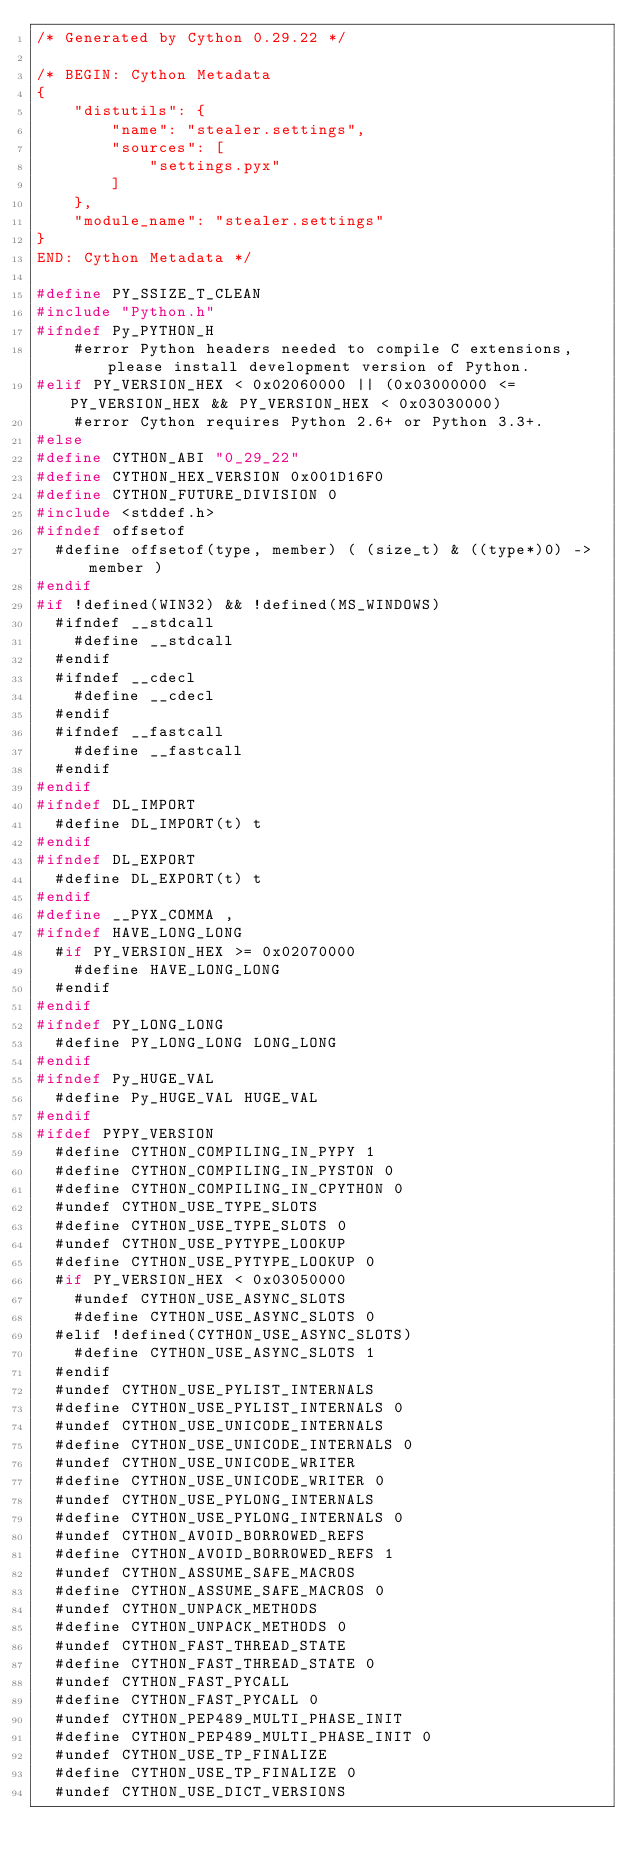<code> <loc_0><loc_0><loc_500><loc_500><_C_>/* Generated by Cython 0.29.22 */

/* BEGIN: Cython Metadata
{
    "distutils": {
        "name": "stealer.settings",
        "sources": [
            "settings.pyx"
        ]
    },
    "module_name": "stealer.settings"
}
END: Cython Metadata */

#define PY_SSIZE_T_CLEAN
#include "Python.h"
#ifndef Py_PYTHON_H
    #error Python headers needed to compile C extensions, please install development version of Python.
#elif PY_VERSION_HEX < 0x02060000 || (0x03000000 <= PY_VERSION_HEX && PY_VERSION_HEX < 0x03030000)
    #error Cython requires Python 2.6+ or Python 3.3+.
#else
#define CYTHON_ABI "0_29_22"
#define CYTHON_HEX_VERSION 0x001D16F0
#define CYTHON_FUTURE_DIVISION 0
#include <stddef.h>
#ifndef offsetof
  #define offsetof(type, member) ( (size_t) & ((type*)0) -> member )
#endif
#if !defined(WIN32) && !defined(MS_WINDOWS)
  #ifndef __stdcall
    #define __stdcall
  #endif
  #ifndef __cdecl
    #define __cdecl
  #endif
  #ifndef __fastcall
    #define __fastcall
  #endif
#endif
#ifndef DL_IMPORT
  #define DL_IMPORT(t) t
#endif
#ifndef DL_EXPORT
  #define DL_EXPORT(t) t
#endif
#define __PYX_COMMA ,
#ifndef HAVE_LONG_LONG
  #if PY_VERSION_HEX >= 0x02070000
    #define HAVE_LONG_LONG
  #endif
#endif
#ifndef PY_LONG_LONG
  #define PY_LONG_LONG LONG_LONG
#endif
#ifndef Py_HUGE_VAL
  #define Py_HUGE_VAL HUGE_VAL
#endif
#ifdef PYPY_VERSION
  #define CYTHON_COMPILING_IN_PYPY 1
  #define CYTHON_COMPILING_IN_PYSTON 0
  #define CYTHON_COMPILING_IN_CPYTHON 0
  #undef CYTHON_USE_TYPE_SLOTS
  #define CYTHON_USE_TYPE_SLOTS 0
  #undef CYTHON_USE_PYTYPE_LOOKUP
  #define CYTHON_USE_PYTYPE_LOOKUP 0
  #if PY_VERSION_HEX < 0x03050000
    #undef CYTHON_USE_ASYNC_SLOTS
    #define CYTHON_USE_ASYNC_SLOTS 0
  #elif !defined(CYTHON_USE_ASYNC_SLOTS)
    #define CYTHON_USE_ASYNC_SLOTS 1
  #endif
  #undef CYTHON_USE_PYLIST_INTERNALS
  #define CYTHON_USE_PYLIST_INTERNALS 0
  #undef CYTHON_USE_UNICODE_INTERNALS
  #define CYTHON_USE_UNICODE_INTERNALS 0
  #undef CYTHON_USE_UNICODE_WRITER
  #define CYTHON_USE_UNICODE_WRITER 0
  #undef CYTHON_USE_PYLONG_INTERNALS
  #define CYTHON_USE_PYLONG_INTERNALS 0
  #undef CYTHON_AVOID_BORROWED_REFS
  #define CYTHON_AVOID_BORROWED_REFS 1
  #undef CYTHON_ASSUME_SAFE_MACROS
  #define CYTHON_ASSUME_SAFE_MACROS 0
  #undef CYTHON_UNPACK_METHODS
  #define CYTHON_UNPACK_METHODS 0
  #undef CYTHON_FAST_THREAD_STATE
  #define CYTHON_FAST_THREAD_STATE 0
  #undef CYTHON_FAST_PYCALL
  #define CYTHON_FAST_PYCALL 0
  #undef CYTHON_PEP489_MULTI_PHASE_INIT
  #define CYTHON_PEP489_MULTI_PHASE_INIT 0
  #undef CYTHON_USE_TP_FINALIZE
  #define CYTHON_USE_TP_FINALIZE 0
  #undef CYTHON_USE_DICT_VERSIONS</code> 